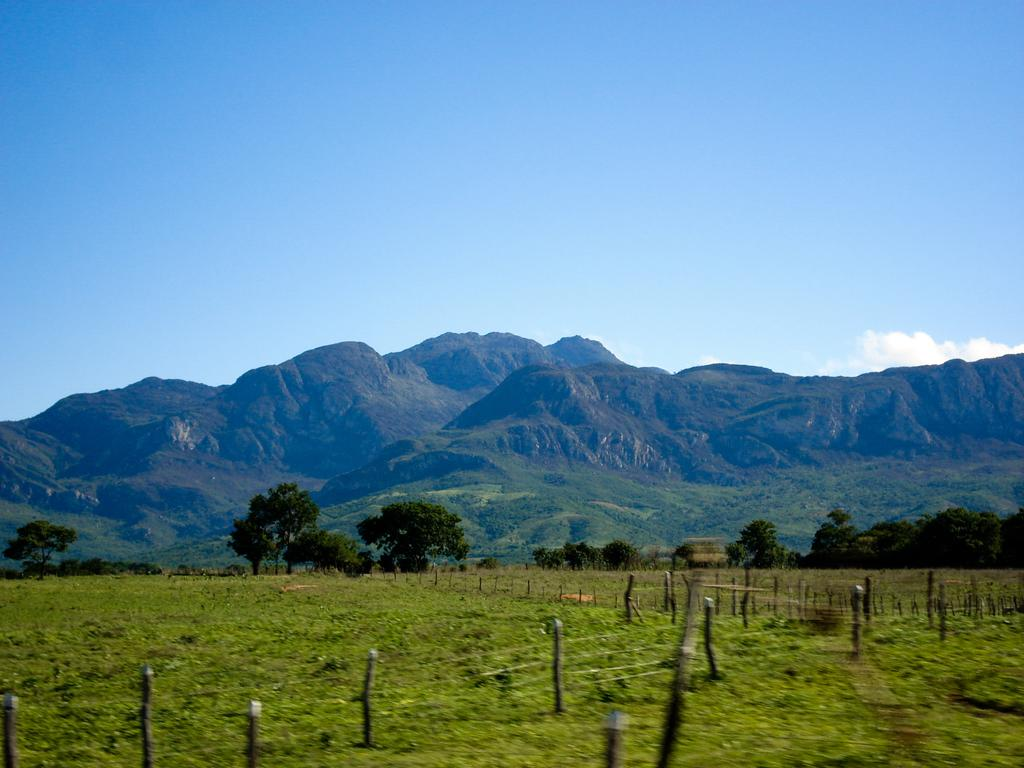What type of vegetation is present in the image? There is grass in the image. What other natural elements can be seen in the image? There are trees and a mountain visible in the image. What is visible in the sky in the image? The sky is visible in the image. What man-made objects are present in the image? There are poles in the image. What type of territory is being claimed by the sock in the image? There is no sock present in the image, and therefore no territory is being claimed. What type of weather condition is depicted in the image? The provided facts do not mention any specific weather condition; only the presence of grass, trees, a mountain, the sky, and poles are mentioned. 